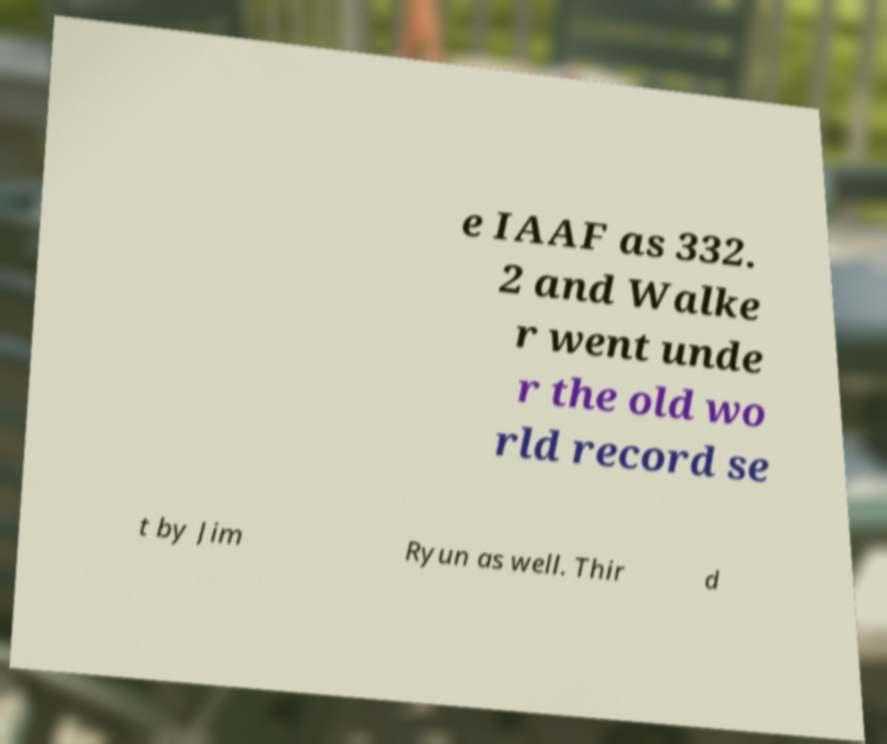Can you accurately transcribe the text from the provided image for me? e IAAF as 332. 2 and Walke r went unde r the old wo rld record se t by Jim Ryun as well. Thir d 